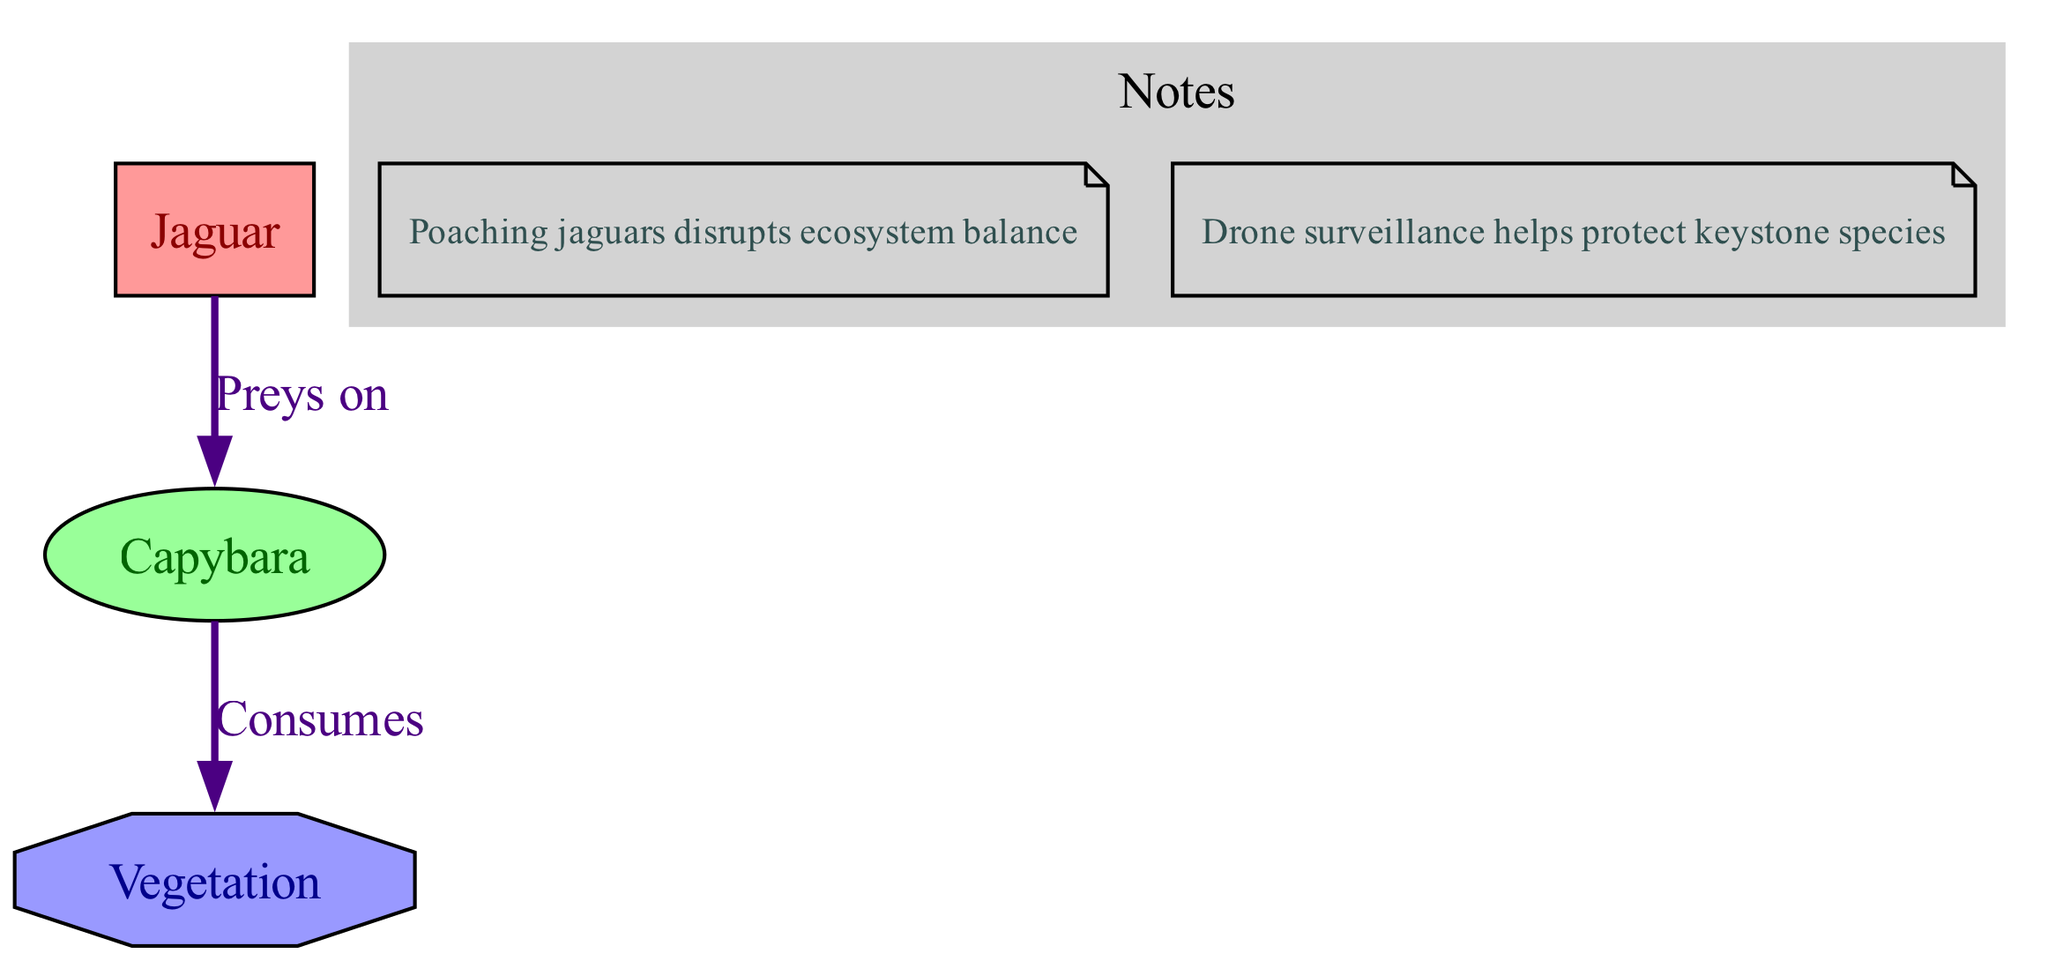What is the apex predator depicted in the diagram? The diagram identifies the "Jaguar" as the apex predator, which is labeled clearly in the node representing it.
Answer: Jaguar How many nodes are in the diagram? By counting all distinct entities represented in the diagram, we find there are three nodes: Jaguar, Capybara, and Vegetation.
Answer: 3 What type of species is the Capybara categorized as? The diagram specifies that the Capybara is categorized as a "Herbivore," which is indicated within its node type.
Answer: Herbivore What does the Jaguar prey on? The edge connecting the Jaguar to the Capybara indicates a direct relationship, where the Jaguar "Preys on" the Capybara, clarifying its role in the food chain.
Answer: Capybara What is the relationship between Capybara and Vegetation? The diagram shows that the Capybara "Consumes" Vegetation, indicating its role as a herbivore in the ecosystem consuming plant matter.
Answer: Consumes Which keystone species is affected by poaching according to the notes? The notes mention that poaching disrupts the ecosystem balance specifically concerning the Jaguar, which is classified as a keystone species in this environment.
Answer: Jaguar What is the purpose of drone surveillance as mentioned in the notes? The notes highlight that drone surveillance is utilized to help protect keystone species, aimed at combatting poaching threats to these vital members of the ecosystem.
Answer: Protect keystone species How does poaching impact Jaguars according to the diagram? The notes point out that poaching of jaguars disrupts the ecosystem balance, suggesting that the removal of this apex predator affects the entire food chain.
Answer: Disrupts ecosystem balance What type of producer is represented in the diagram? The diagram classifies Vegetation as a "Producer," and this is noted within the node that represents it, indicating its functional role in the ecosystem.
Answer: Producer 